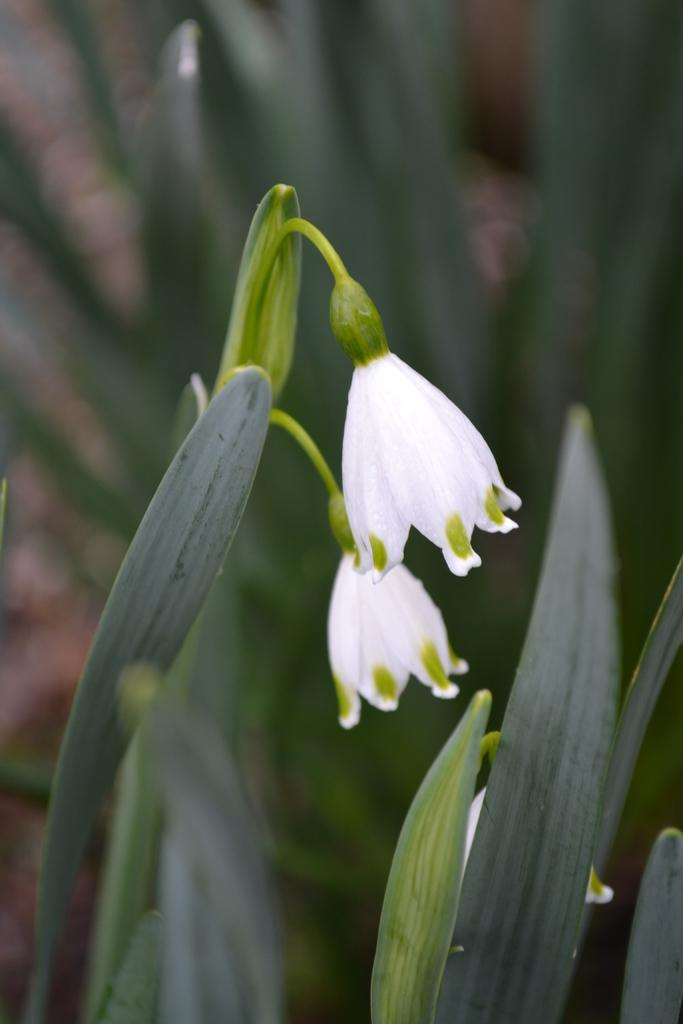What type of plants can be seen in the image? There are plants with flowers in the image. Can you describe the background of the image? The background of the image is blurry. What type of box is the judge holding in the image? There is no judge or box present in the image; it features plants with flowers and a blurry background. 